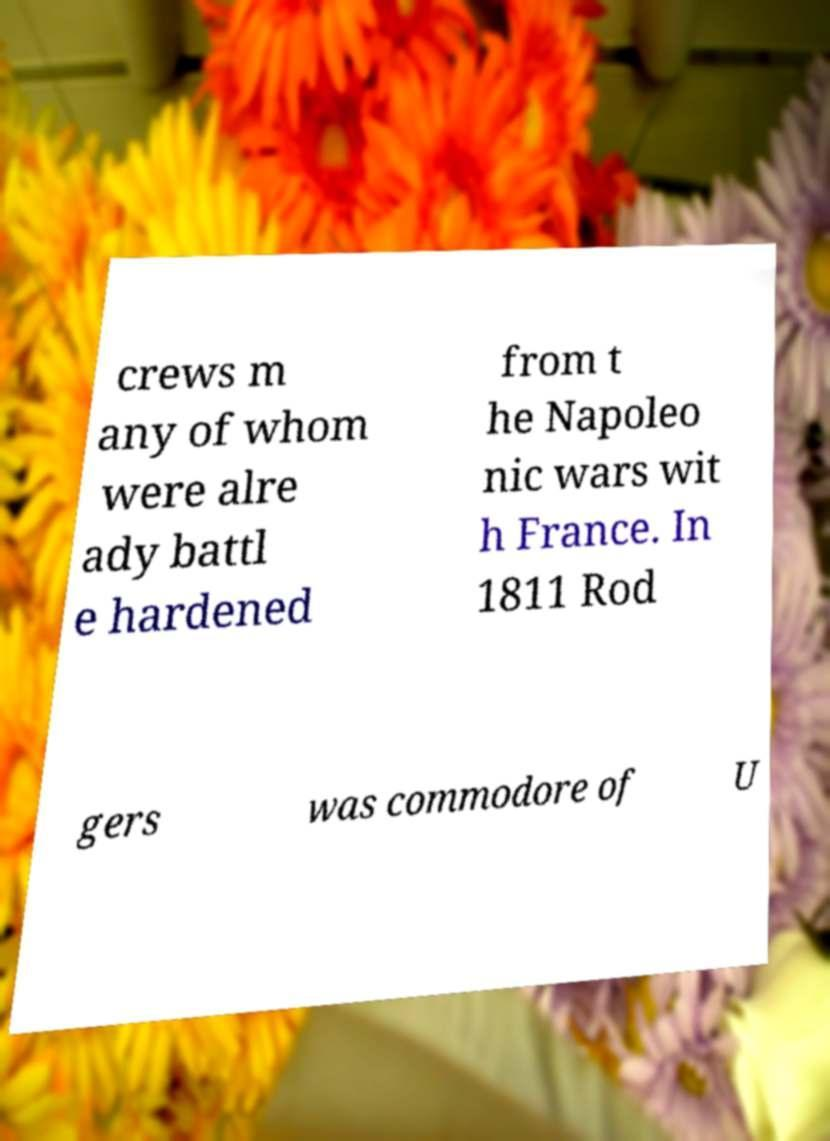There's text embedded in this image that I need extracted. Can you transcribe it verbatim? crews m any of whom were alre ady battl e hardened from t he Napoleo nic wars wit h France. In 1811 Rod gers was commodore of U 